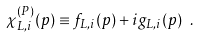<formula> <loc_0><loc_0><loc_500><loc_500>\chi ^ { ( P ) } _ { L , i } ( p ) \equiv f _ { L , i } ( p ) + i g _ { L , i } ( p ) \ .</formula> 